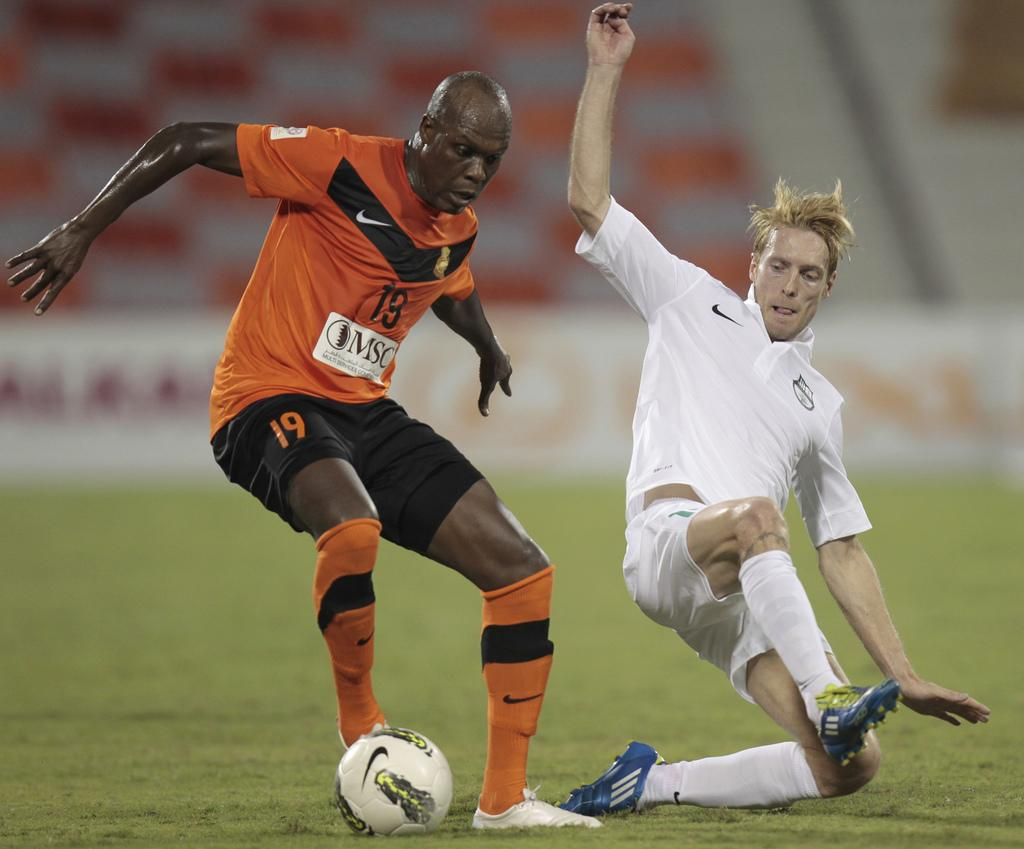How many people are in the image? There are two persons in the image. What are the two persons doing in the image? The two persons are playing football. What song is the mother singing in the image? There is no mother or song present in the image; it features two persons playing football. 